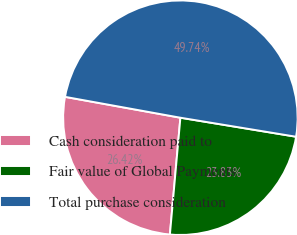Convert chart. <chart><loc_0><loc_0><loc_500><loc_500><pie_chart><fcel>Cash consideration paid to<fcel>Fair value of Global Payments<fcel>Total purchase consideration<nl><fcel>26.42%<fcel>23.83%<fcel>49.74%<nl></chart> 